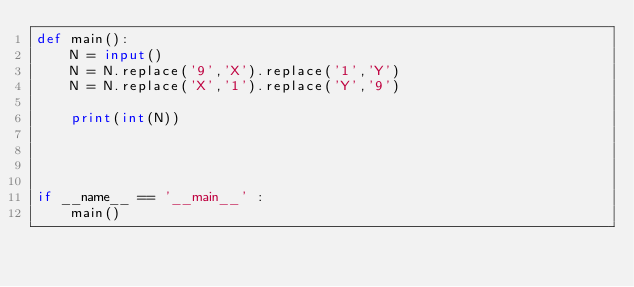Convert code to text. <code><loc_0><loc_0><loc_500><loc_500><_Python_>def main():
    N = input()
    N = N.replace('9','X').replace('1','Y')
    N = N.replace('X','1').replace('Y','9')
    
    print(int(N))




if __name__ == '__main__' :
    main()</code> 